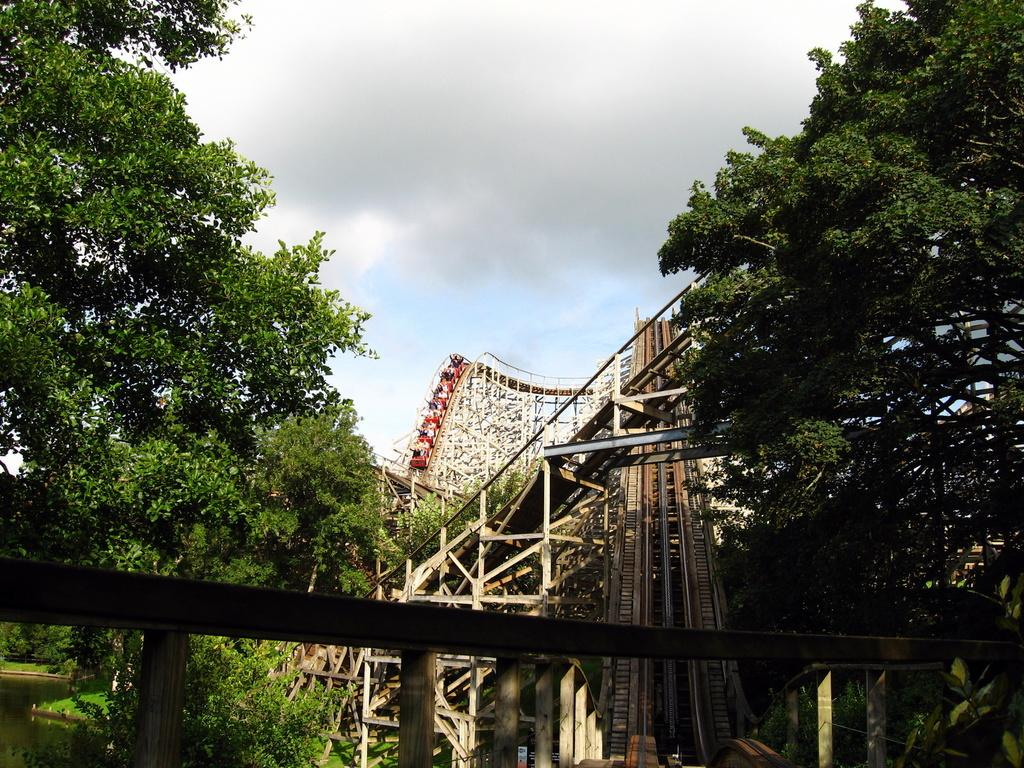What is the main structure in the center of the image? There is a bridge in the center of the image. What can be seen in the background of the image? There are trees and fun rides visible in the background of the image. What is present at the bottom left of the image? There is water on the bottom left of the image. What type of reward can be seen hanging from the bridge in the image? There is no reward hanging from the bridge in the image; it is a simple structure connecting two areas. 